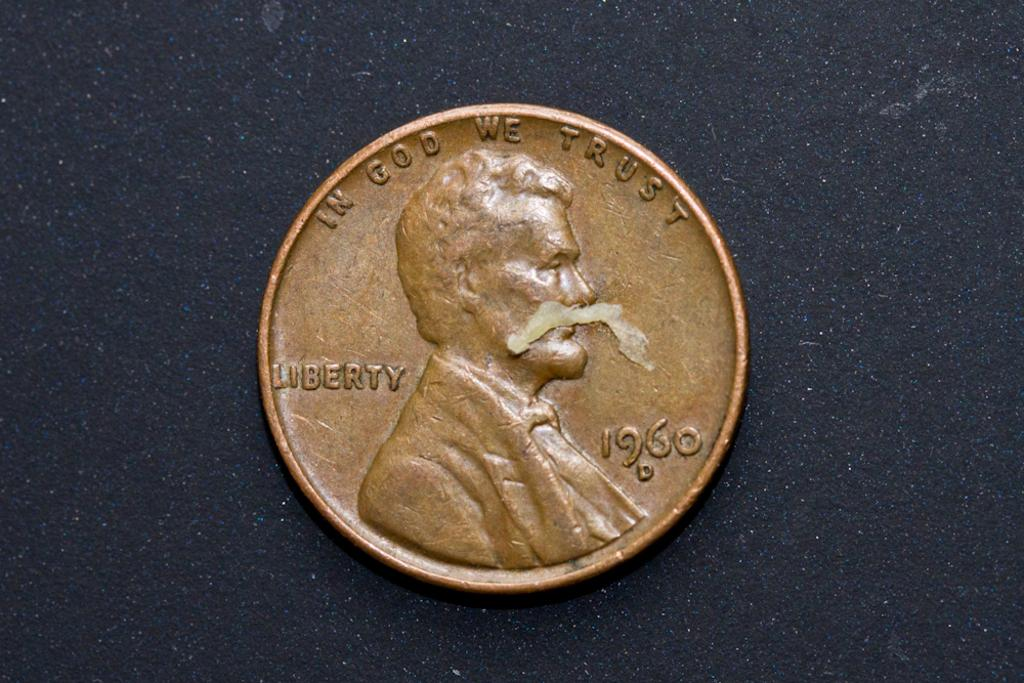<image>
Describe the image concisely. A penny made in 1960 says in God we Trust at the top. 